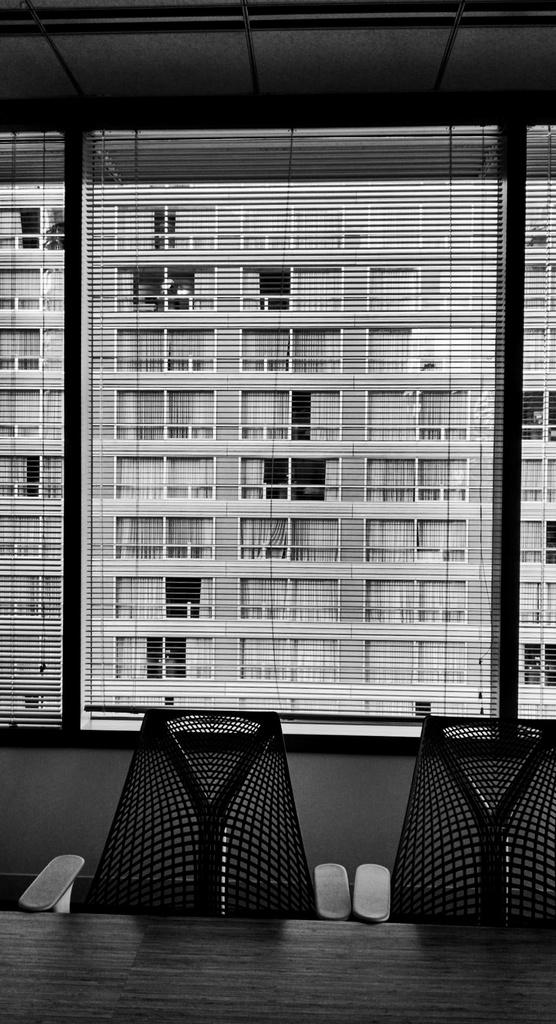What type of furniture is present in the image? There are chairs in the image. What other piece of furniture can be seen in the image? There is a table in the image. What is visible in the background of the image? There is a building in the background of the image. How is the image presented in terms of color? The photography is in black and white. Did the chairs and table experience an earthquake during the photography session? There is no indication of an earthquake or any other natural disaster in the image. 